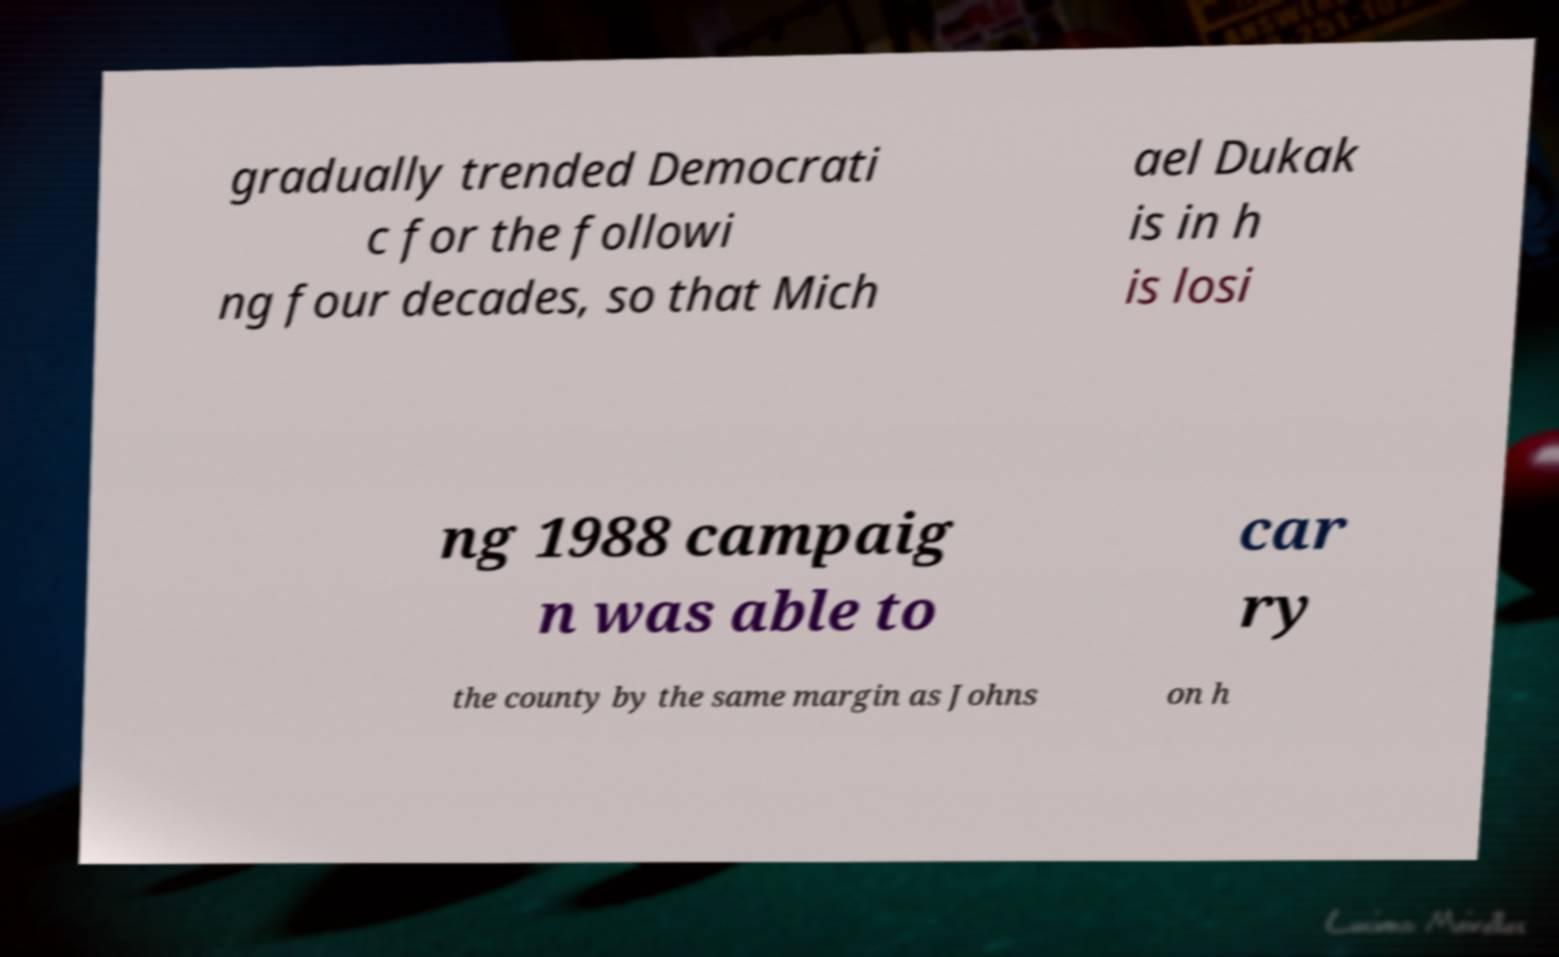I need the written content from this picture converted into text. Can you do that? gradually trended Democrati c for the followi ng four decades, so that Mich ael Dukak is in h is losi ng 1988 campaig n was able to car ry the county by the same margin as Johns on h 